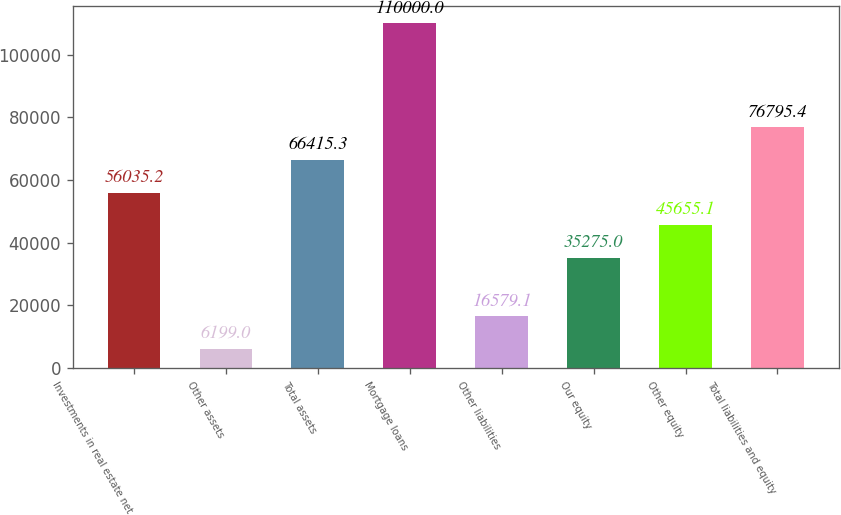Convert chart. <chart><loc_0><loc_0><loc_500><loc_500><bar_chart><fcel>Investments in real estate net<fcel>Other assets<fcel>Total assets<fcel>Mortgage loans<fcel>Other liabilities<fcel>Our equity<fcel>Other equity<fcel>Total liabilities and equity<nl><fcel>56035.2<fcel>6199<fcel>66415.3<fcel>110000<fcel>16579.1<fcel>35275<fcel>45655.1<fcel>76795.4<nl></chart> 